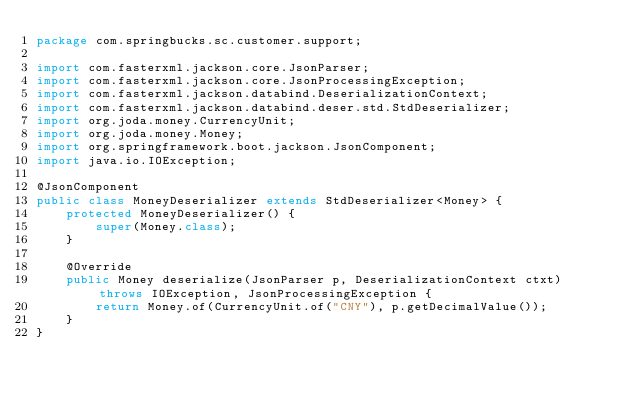Convert code to text. <code><loc_0><loc_0><loc_500><loc_500><_Java_>package com.springbucks.sc.customer.support;

import com.fasterxml.jackson.core.JsonParser;
import com.fasterxml.jackson.core.JsonProcessingException;
import com.fasterxml.jackson.databind.DeserializationContext;
import com.fasterxml.jackson.databind.deser.std.StdDeserializer;
import org.joda.money.CurrencyUnit;
import org.joda.money.Money;
import org.springframework.boot.jackson.JsonComponent;
import java.io.IOException;

@JsonComponent
public class MoneyDeserializer extends StdDeserializer<Money> {
    protected MoneyDeserializer() {
        super(Money.class);
    }

    @Override
    public Money deserialize(JsonParser p, DeserializationContext ctxt) throws IOException, JsonProcessingException {
        return Money.of(CurrencyUnit.of("CNY"), p.getDecimalValue());
    }
}
</code> 